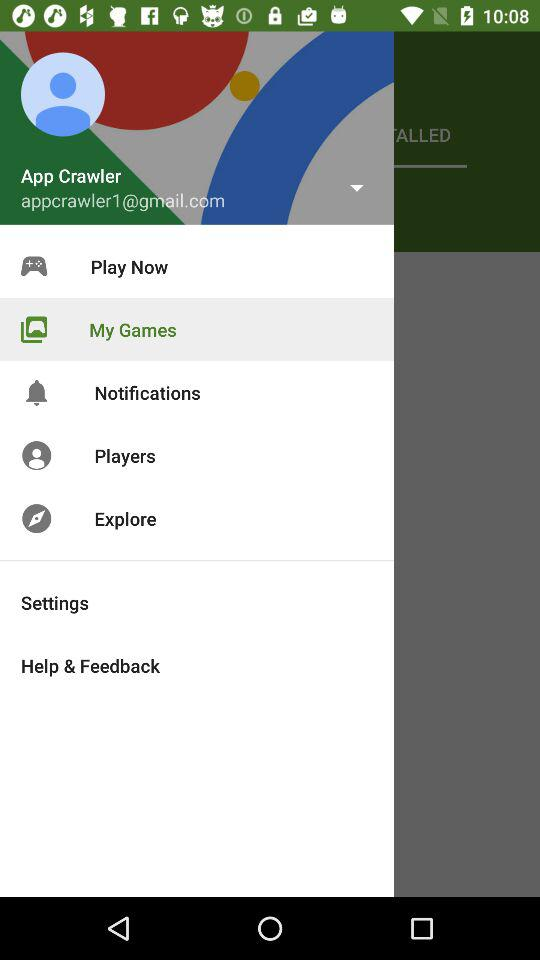What is the username? The username is App Crawler. 